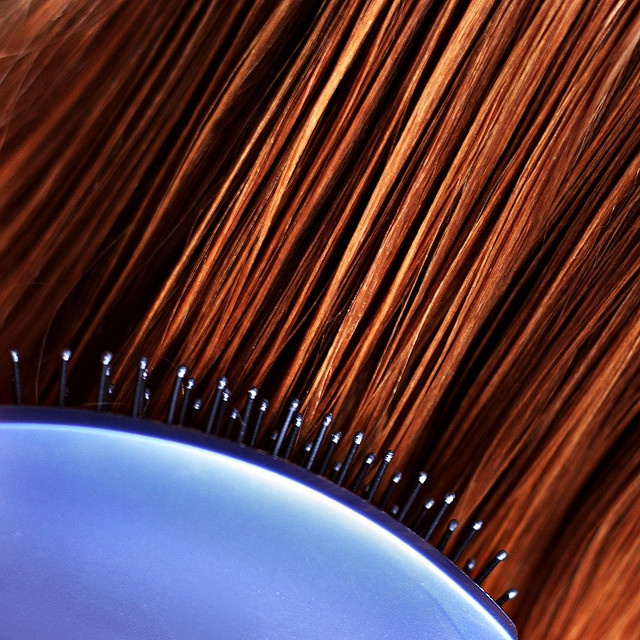Describe the objects in this image and their specific colors. I can see various objects in this image with different colors. 